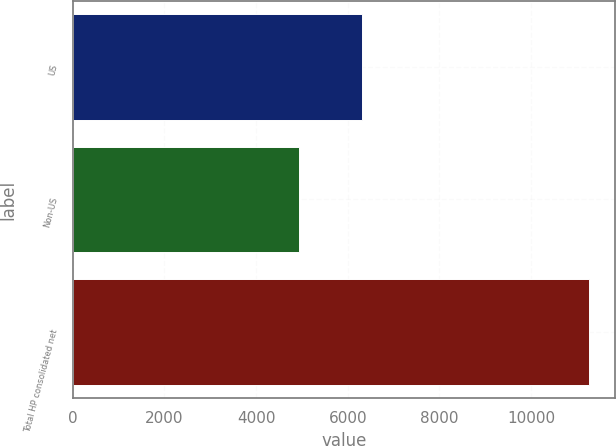Convert chart. <chart><loc_0><loc_0><loc_500><loc_500><bar_chart><fcel>US<fcel>Non-US<fcel>Total HP consolidated net<nl><fcel>6316<fcel>4946<fcel>11262<nl></chart> 